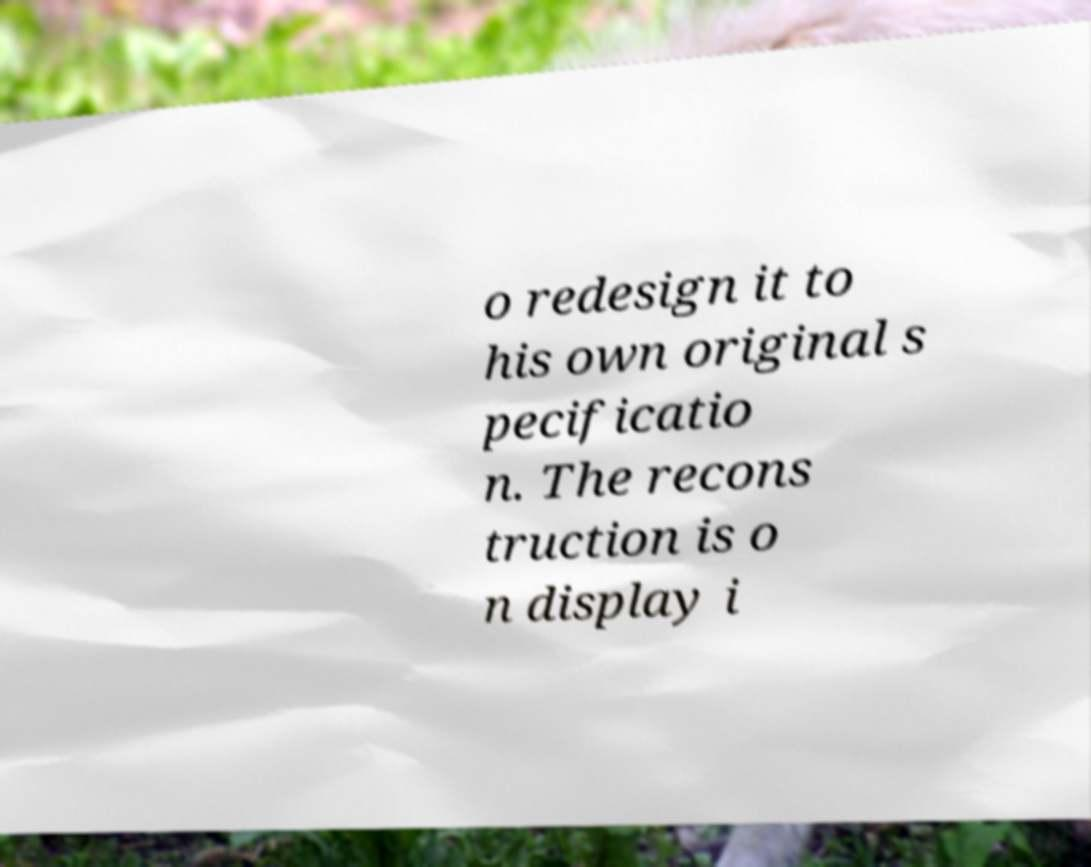Can you accurately transcribe the text from the provided image for me? o redesign it to his own original s pecificatio n. The recons truction is o n display i 